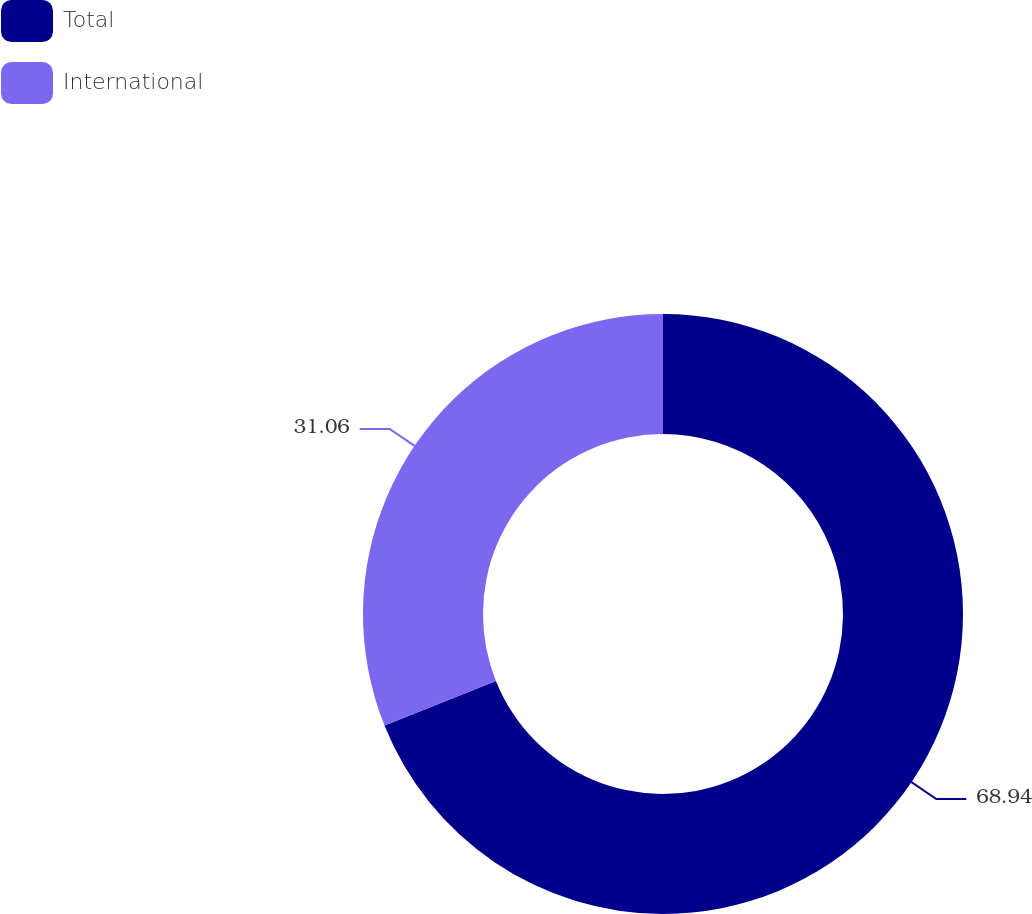Convert chart. <chart><loc_0><loc_0><loc_500><loc_500><pie_chart><fcel>Total<fcel>International<nl><fcel>68.94%<fcel>31.06%<nl></chart> 